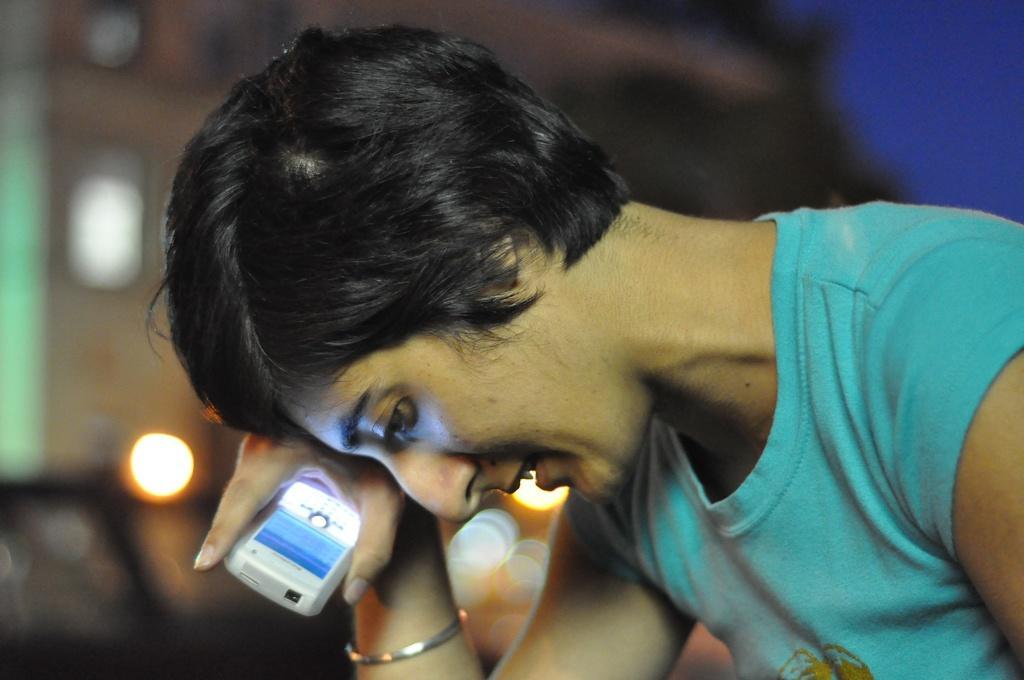Please provide a concise description of this image. In this image, we can see a person is holding and object. Background we can see a blur view. 